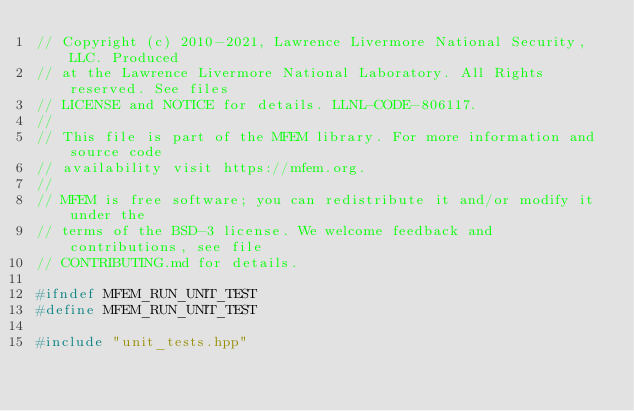<code> <loc_0><loc_0><loc_500><loc_500><_C++_>// Copyright (c) 2010-2021, Lawrence Livermore National Security, LLC. Produced
// at the Lawrence Livermore National Laboratory. All Rights reserved. See files
// LICENSE and NOTICE for details. LLNL-CODE-806117.
//
// This file is part of the MFEM library. For more information and source code
// availability visit https://mfem.org.
//
// MFEM is free software; you can redistribute it and/or modify it under the
// terms of the BSD-3 license. We welcome feedback and contributions, see file
// CONTRIBUTING.md for details.

#ifndef MFEM_RUN_UNIT_TEST
#define MFEM_RUN_UNIT_TEST

#include "unit_tests.hpp"
</code> 